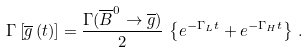<formula> <loc_0><loc_0><loc_500><loc_500>\Gamma \left [ \overline { g } \left ( t \right ) \right ] = \frac { \Gamma ( \overline { B } ^ { 0 } \rightarrow \overline { g } ) } { 2 } \, \left \{ e ^ { - \Gamma _ { L } t } + e ^ { - \Gamma _ { H } t } \right \} \, .</formula> 